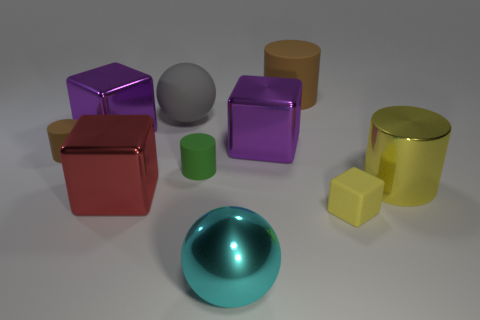Is the large shiny cylinder the same color as the small block?
Your response must be concise. Yes. There is a rubber block that is the same color as the big metallic cylinder; what is its size?
Give a very brief answer. Small. There is a tiny cylinder that is the same color as the big matte cylinder; what is it made of?
Give a very brief answer. Rubber. Are any tiny blue shiny cylinders visible?
Keep it short and to the point. No. There is a small brown object that is the same shape as the large brown matte thing; what is its material?
Offer a very short reply. Rubber. There is a cyan thing; are there any small matte things right of it?
Provide a succinct answer. Yes. Do the brown thing on the left side of the big matte cylinder and the large brown thing have the same material?
Your response must be concise. Yes. Is there a big object of the same color as the tiny rubber cube?
Provide a short and direct response. Yes. There is a big cyan thing; what shape is it?
Offer a very short reply. Sphere. What color is the small rubber object that is in front of the big cylinder that is to the right of the small yellow matte cube?
Provide a succinct answer. Yellow. 